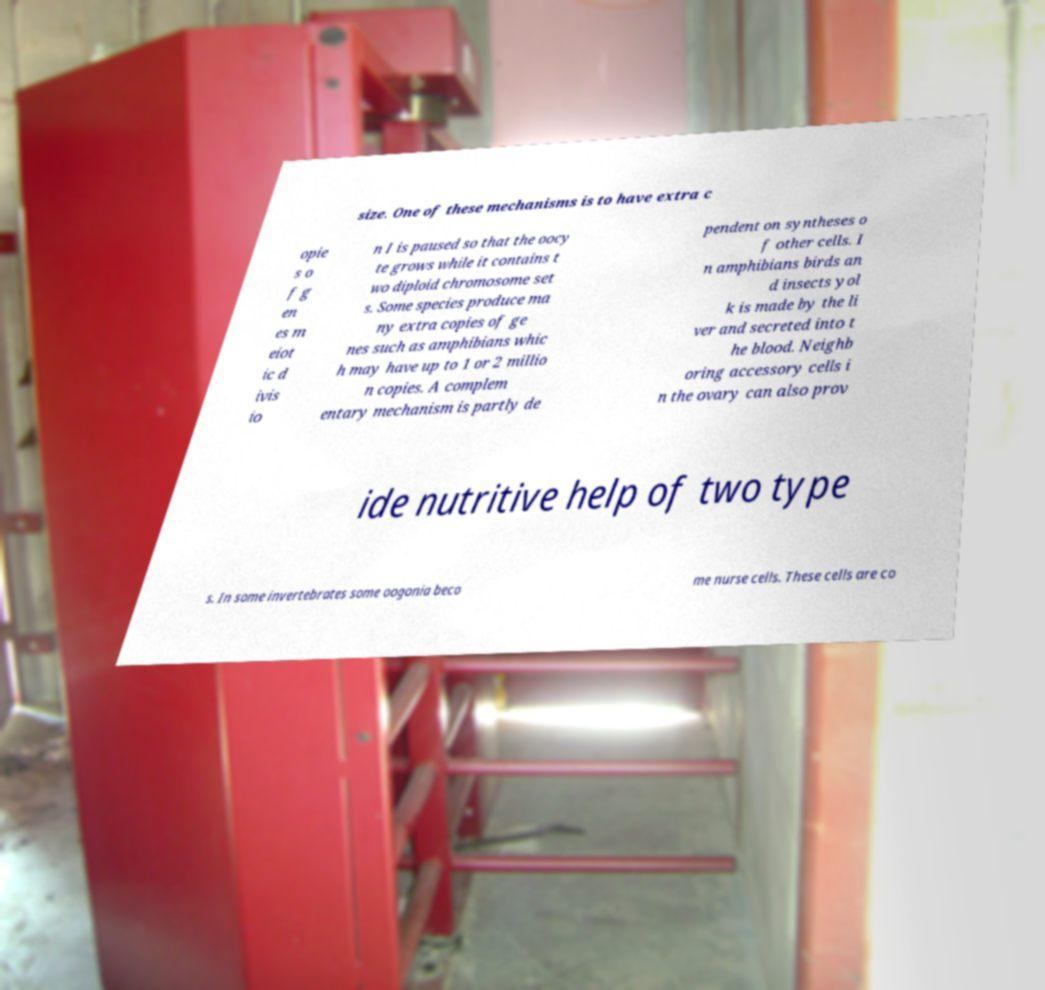I need the written content from this picture converted into text. Can you do that? size. One of these mechanisms is to have extra c opie s o f g en es m eiot ic d ivis io n I is paused so that the oocy te grows while it contains t wo diploid chromosome set s. Some species produce ma ny extra copies of ge nes such as amphibians whic h may have up to 1 or 2 millio n copies. A complem entary mechanism is partly de pendent on syntheses o f other cells. I n amphibians birds an d insects yol k is made by the li ver and secreted into t he blood. Neighb oring accessory cells i n the ovary can also prov ide nutritive help of two type s. In some invertebrates some oogonia beco me nurse cells. These cells are co 